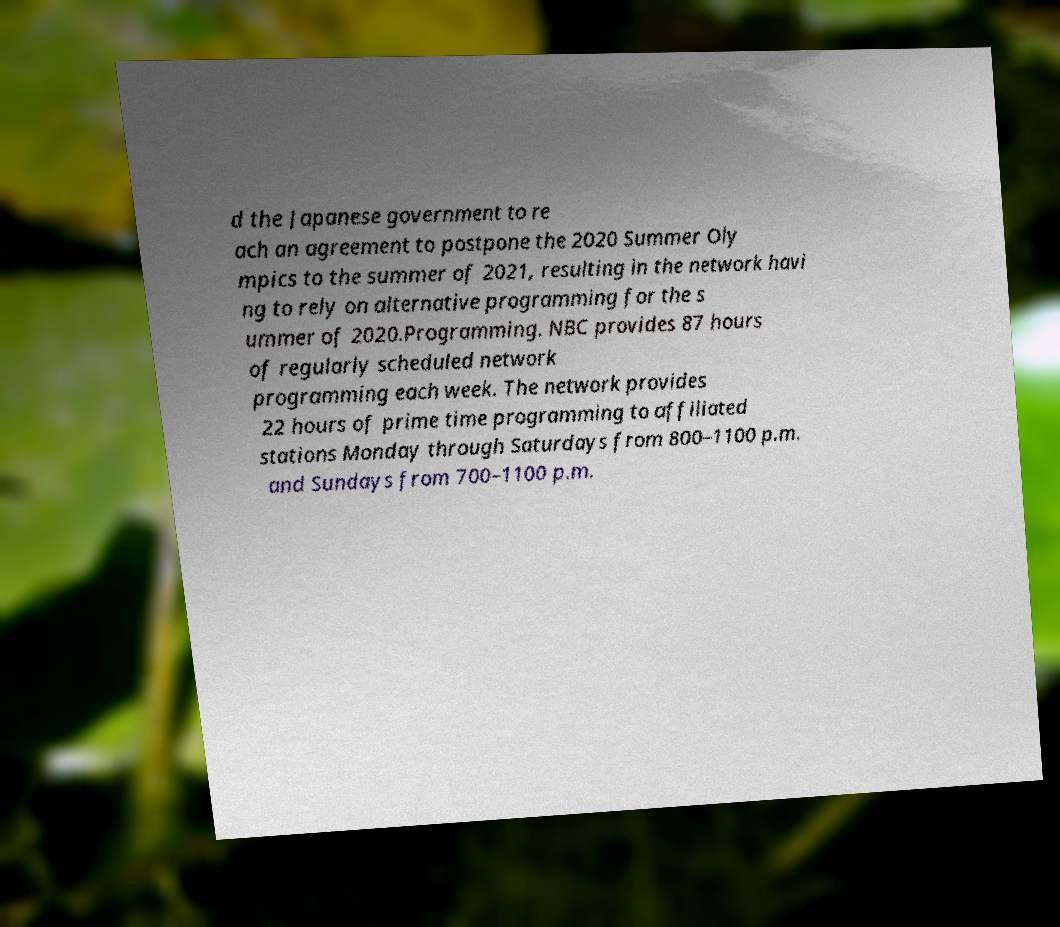I need the written content from this picture converted into text. Can you do that? d the Japanese government to re ach an agreement to postpone the 2020 Summer Oly mpics to the summer of 2021, resulting in the network havi ng to rely on alternative programming for the s ummer of 2020.Programming. NBC provides 87 hours of regularly scheduled network programming each week. The network provides 22 hours of prime time programming to affiliated stations Monday through Saturdays from 800–1100 p.m. and Sundays from 700–1100 p.m. 